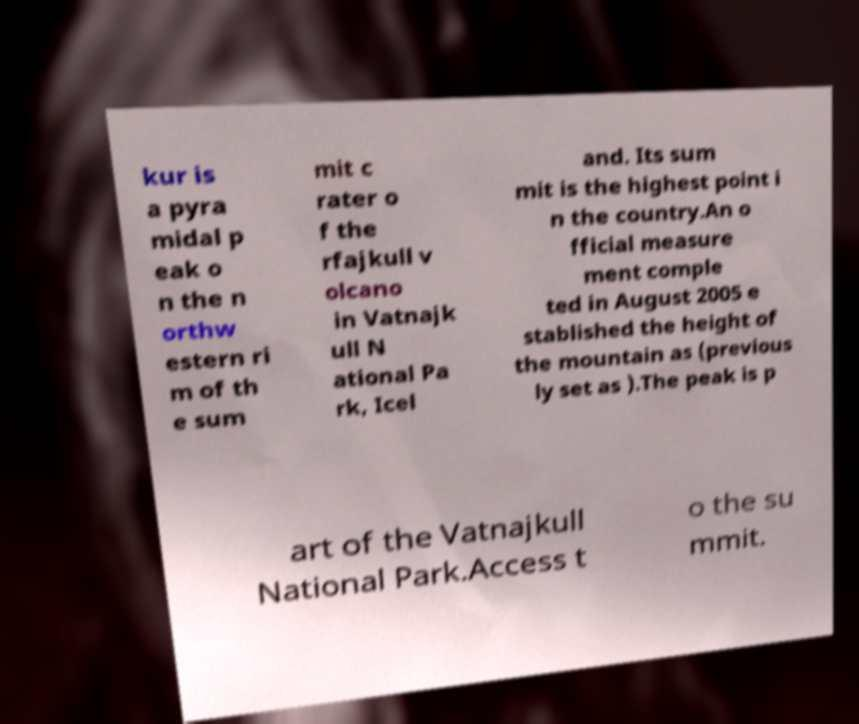For documentation purposes, I need the text within this image transcribed. Could you provide that? kur is a pyra midal p eak o n the n orthw estern ri m of th e sum mit c rater o f the rfajkull v olcano in Vatnajk ull N ational Pa rk, Icel and. Its sum mit is the highest point i n the country.An o fficial measure ment comple ted in August 2005 e stablished the height of the mountain as (previous ly set as ).The peak is p art of the Vatnajkull National Park.Access t o the su mmit. 